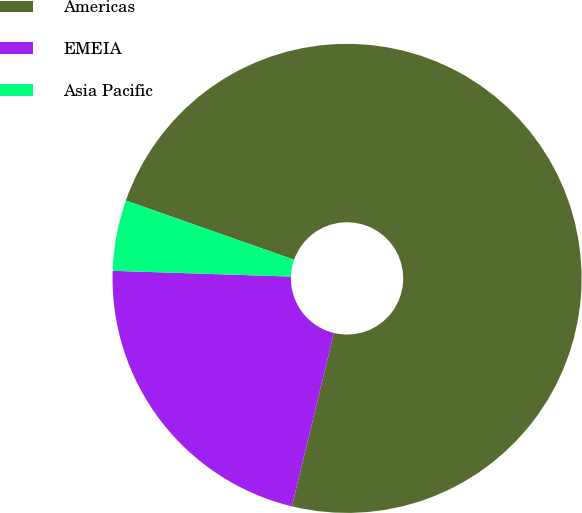<chart> <loc_0><loc_0><loc_500><loc_500><pie_chart><fcel>Americas<fcel>EMEIA<fcel>Asia Pacific<nl><fcel>73.4%<fcel>21.74%<fcel>4.87%<nl></chart> 